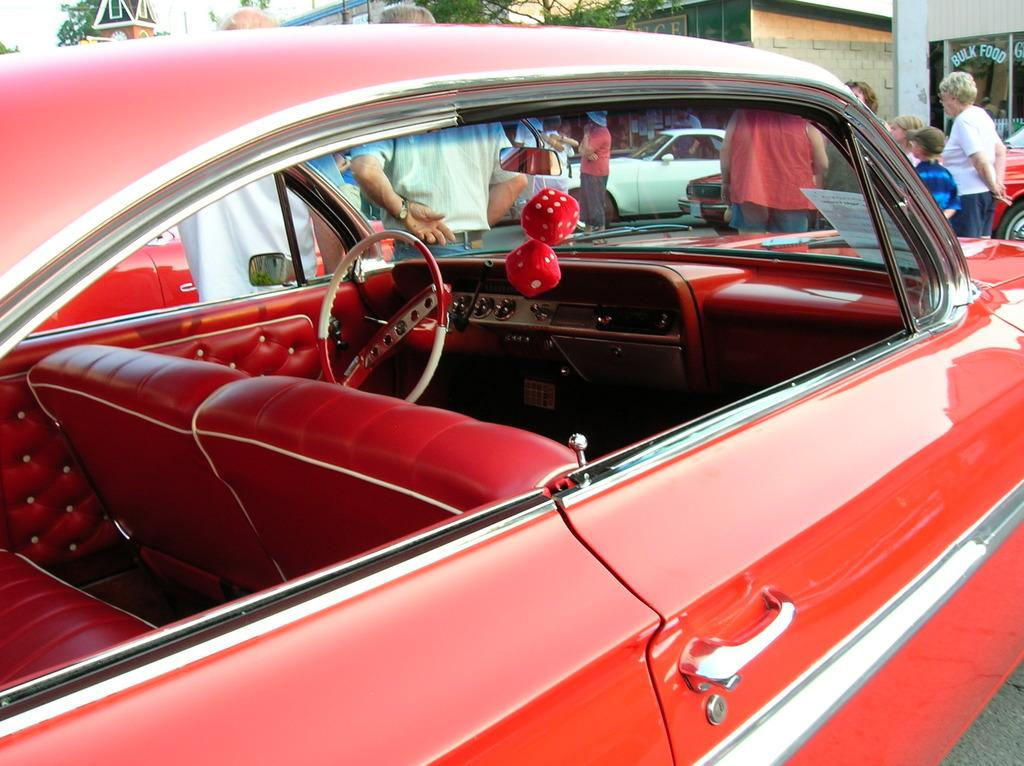What color is the car in the image? The car in the image is red. Who or what else can be seen in the image besides the car? There are people in the image. What can be seen in the distance behind the car and people? There are buildings and trees visible in the background. What type of yam is being used as a writing instrument in the image? There is no yam or writing activity present in the image. 